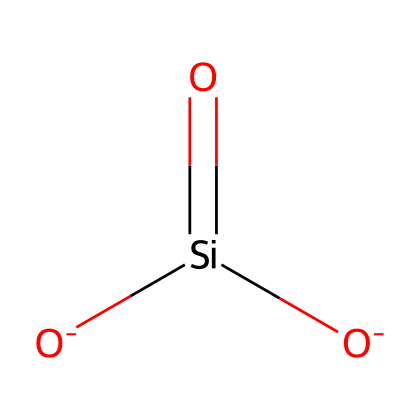What is the chemical name of this compound? The SMILES representation shows the elements silicon (Si) and oxygen (O), and based on its structure, it is identified as silica, also commonly referred to as silicon dioxide.
Answer: silica How many oxygen atoms are present in the chemical structure? The SMILES shows the presence of two oxygen atoms ([O-]), as indicated by the two occurrences of O in the structure.
Answer: two What is the total number of bonds in the chemical structure? By analyzing the SMILES, there are two double bonds (each Si=O bond is one double bond) and two single bonds (each O- bond to Si). So, the total number of bonds is four.
Answer: four Is this compound ionically or covalently bonded? The structure shows silicon is bonded with oxygen through covalent bonds (both elements share electrons rather than transfer them), characteristic of non-metallic bonding.
Answer: covalently Which type of chemical is it primarily used as in food products? This compound is primarily used as an anti-caking agent in food products to prevent clumping by maintaining flowability of powders due to its silica structure.
Answer: anti-caking agent How does the presence of silicon affect the properties of the compound? Silicon's presence in the compound contributes to its rigidity and low reactivity, which enhances its effectiveness for the intended use of preventing caking in spices.
Answer: rigidity In what form is silica typically found in organic spice blends? Silica is commonly found in a powdered form as finely ground particles, which allows it to be dispersed evenly in spice blends to inhibit moisture.
Answer: powdered 